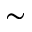Convert formula to latex. <formula><loc_0><loc_0><loc_500><loc_500>\sim</formula> 